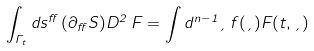Convert formula to latex. <formula><loc_0><loc_0><loc_500><loc_500>\int _ { \Gamma _ { t } } d s ^ { \alpha } \, ( \partial _ { \alpha } S ) D ^ { 2 } \, F = \int d ^ { n - 1 } \xi \, f ( \xi ) F ( t , \xi )</formula> 